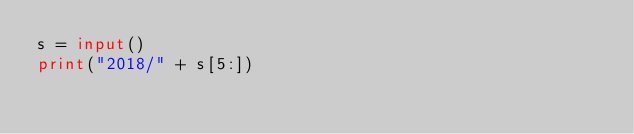<code> <loc_0><loc_0><loc_500><loc_500><_Python_>s = input()
print("2018/" + s[5:])</code> 